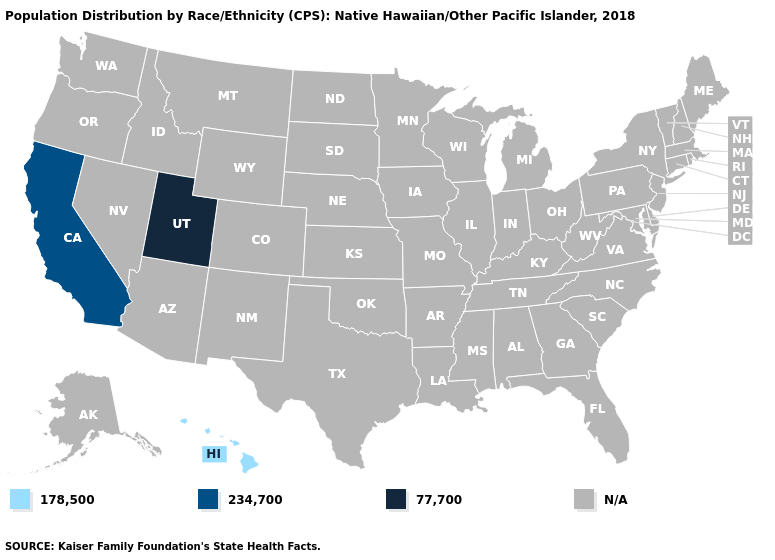What is the value of New Mexico?
Give a very brief answer. N/A. Name the states that have a value in the range 234,700?
Be succinct. California. What is the lowest value in the West?
Concise answer only. 178,500. Name the states that have a value in the range 77,700?
Answer briefly. Utah. What is the value of Vermont?
Answer briefly. N/A. Name the states that have a value in the range 178,500?
Quick response, please. Hawaii. What is the value of Alaska?
Keep it brief. N/A. Name the states that have a value in the range 234,700?
Keep it brief. California. Does Utah have the highest value in the USA?
Answer briefly. Yes. Which states have the highest value in the USA?
Concise answer only. Utah. Name the states that have a value in the range 77,700?
Quick response, please. Utah. What is the value of Arkansas?
Quick response, please. N/A. 